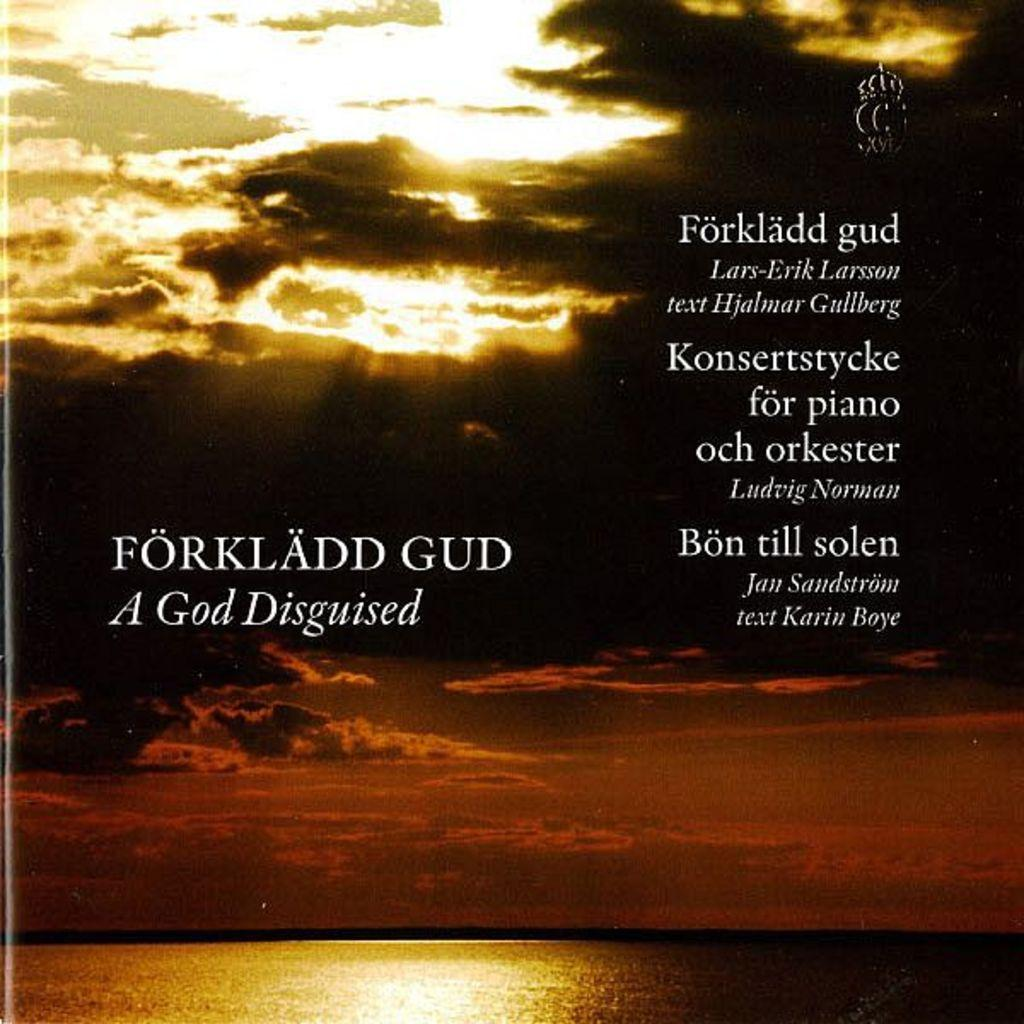<image>
Describe the image concisely. A darkened and cloudy sky with the text forkladd gud a god disguised on the left side. 